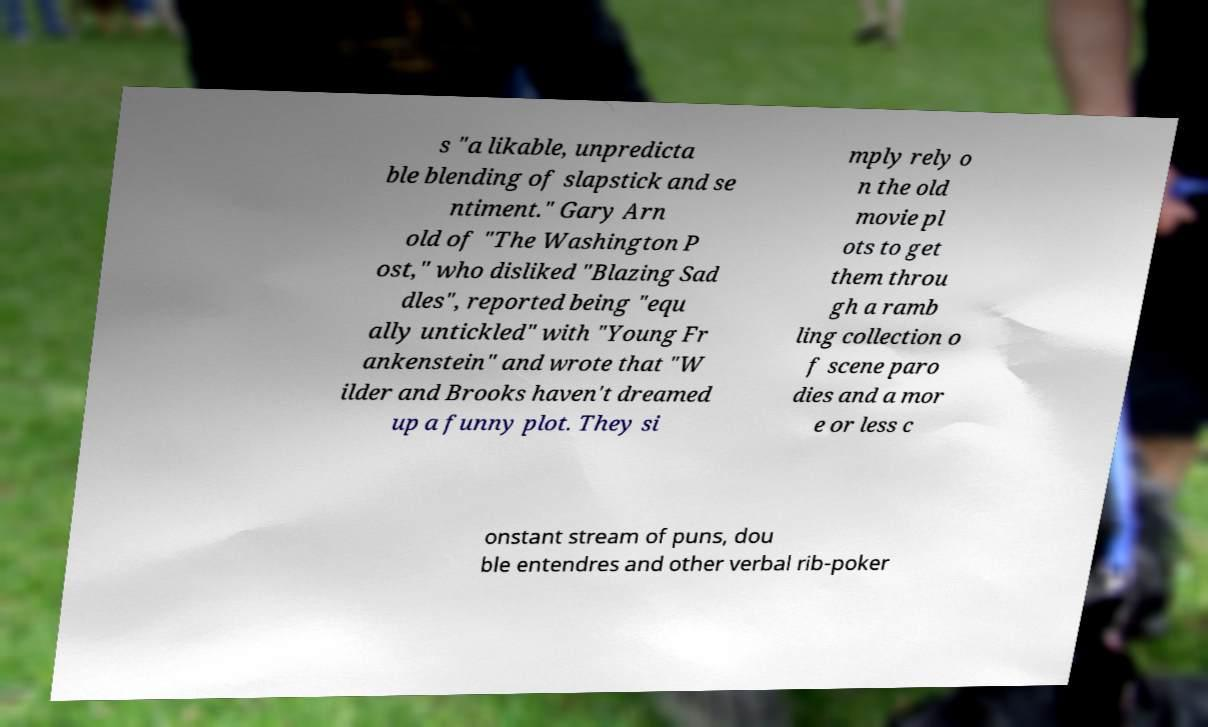I need the written content from this picture converted into text. Can you do that? s "a likable, unpredicta ble blending of slapstick and se ntiment." Gary Arn old of "The Washington P ost," who disliked "Blazing Sad dles", reported being "equ ally untickled" with "Young Fr ankenstein" and wrote that "W ilder and Brooks haven't dreamed up a funny plot. They si mply rely o n the old movie pl ots to get them throu gh a ramb ling collection o f scene paro dies and a mor e or less c onstant stream of puns, dou ble entendres and other verbal rib-poker 